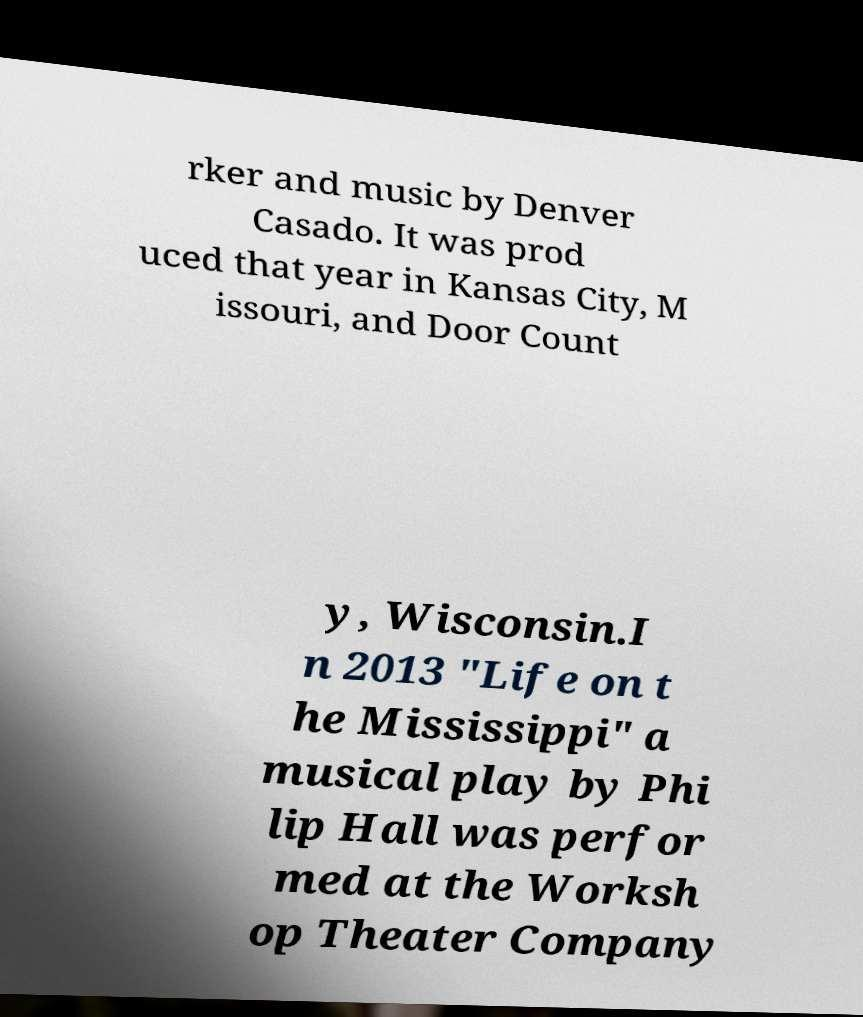Could you assist in decoding the text presented in this image and type it out clearly? rker and music by Denver Casado. It was prod uced that year in Kansas City, M issouri, and Door Count y, Wisconsin.I n 2013 "Life on t he Mississippi" a musical play by Phi lip Hall was perfor med at the Worksh op Theater Company 